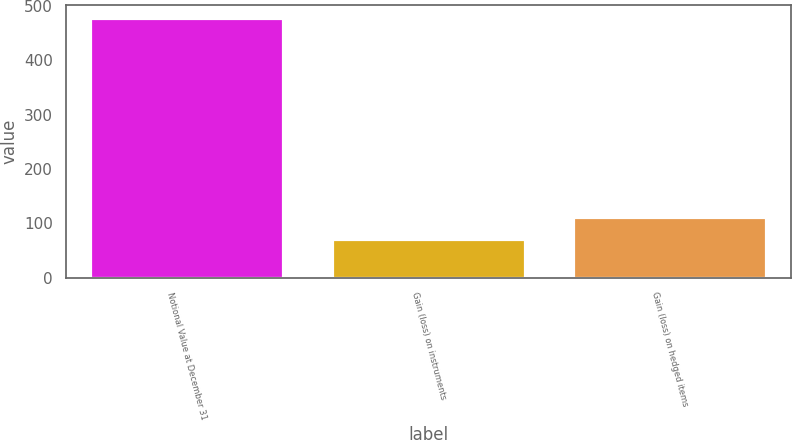<chart> <loc_0><loc_0><loc_500><loc_500><bar_chart><fcel>Notional Value at December 31<fcel>Gain (loss) on instruments<fcel>Gain (loss) on hedged items<nl><fcel>478<fcel>71<fcel>111.7<nl></chart> 